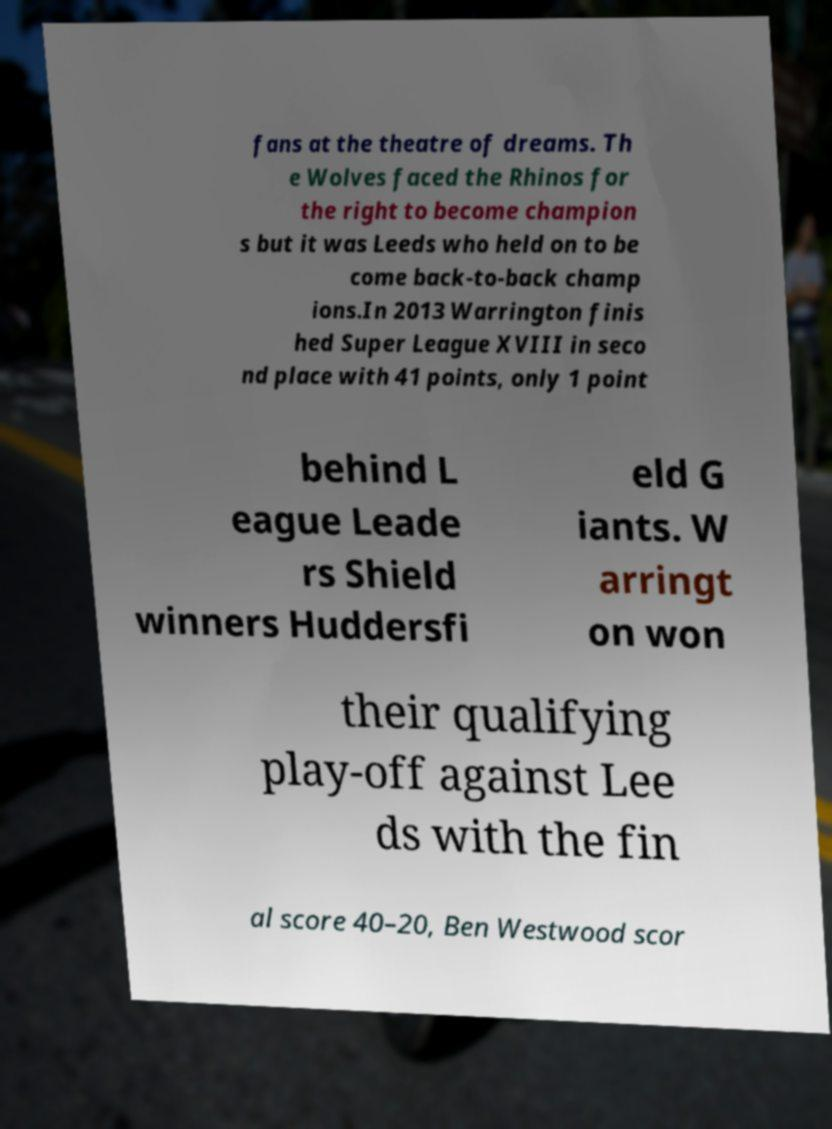Can you accurately transcribe the text from the provided image for me? fans at the theatre of dreams. Th e Wolves faced the Rhinos for the right to become champion s but it was Leeds who held on to be come back-to-back champ ions.In 2013 Warrington finis hed Super League XVIII in seco nd place with 41 points, only 1 point behind L eague Leade rs Shield winners Huddersfi eld G iants. W arringt on won their qualifying play-off against Lee ds with the fin al score 40–20, Ben Westwood scor 